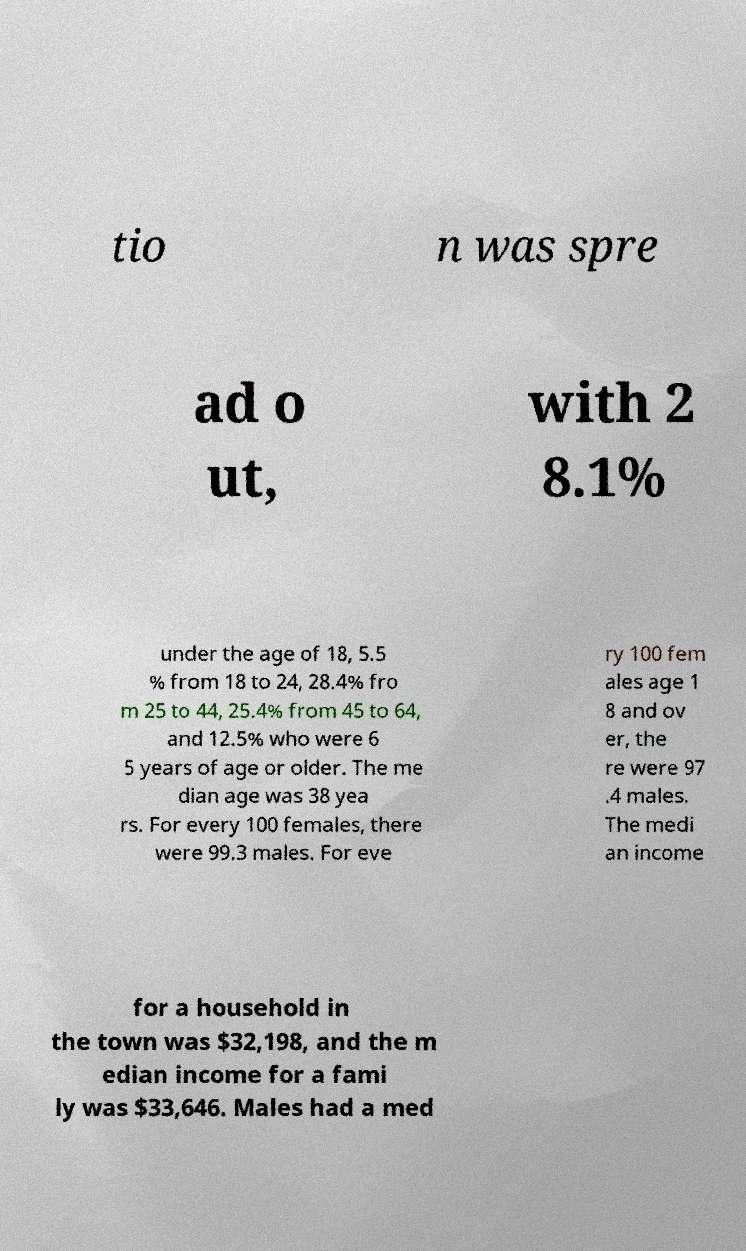Can you read and provide the text displayed in the image?This photo seems to have some interesting text. Can you extract and type it out for me? tio n was spre ad o ut, with 2 8.1% under the age of 18, 5.5 % from 18 to 24, 28.4% fro m 25 to 44, 25.4% from 45 to 64, and 12.5% who were 6 5 years of age or older. The me dian age was 38 yea rs. For every 100 females, there were 99.3 males. For eve ry 100 fem ales age 1 8 and ov er, the re were 97 .4 males. The medi an income for a household in the town was $32,198, and the m edian income for a fami ly was $33,646. Males had a med 